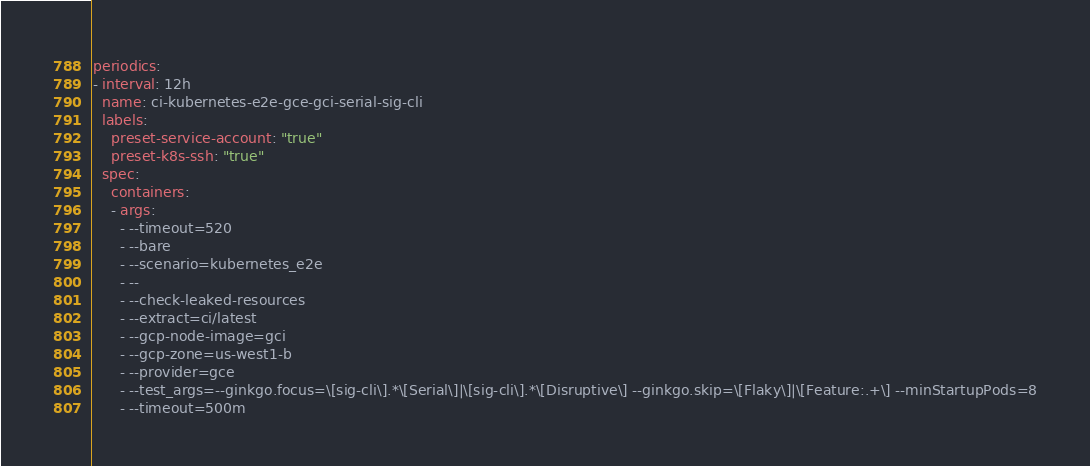<code> <loc_0><loc_0><loc_500><loc_500><_YAML_>periodics:
- interval: 12h
  name: ci-kubernetes-e2e-gce-gci-serial-sig-cli
  labels:
    preset-service-account: "true"
    preset-k8s-ssh: "true"
  spec:
    containers:
    - args:
      - --timeout=520
      - --bare
      - --scenario=kubernetes_e2e
      - --
      - --check-leaked-resources
      - --extract=ci/latest
      - --gcp-node-image=gci
      - --gcp-zone=us-west1-b
      - --provider=gce
      - --test_args=--ginkgo.focus=\[sig-cli\].*\[Serial\]|\[sig-cli\].*\[Disruptive\] --ginkgo.skip=\[Flaky\]|\[Feature:.+\] --minStartupPods=8
      - --timeout=500m</code> 